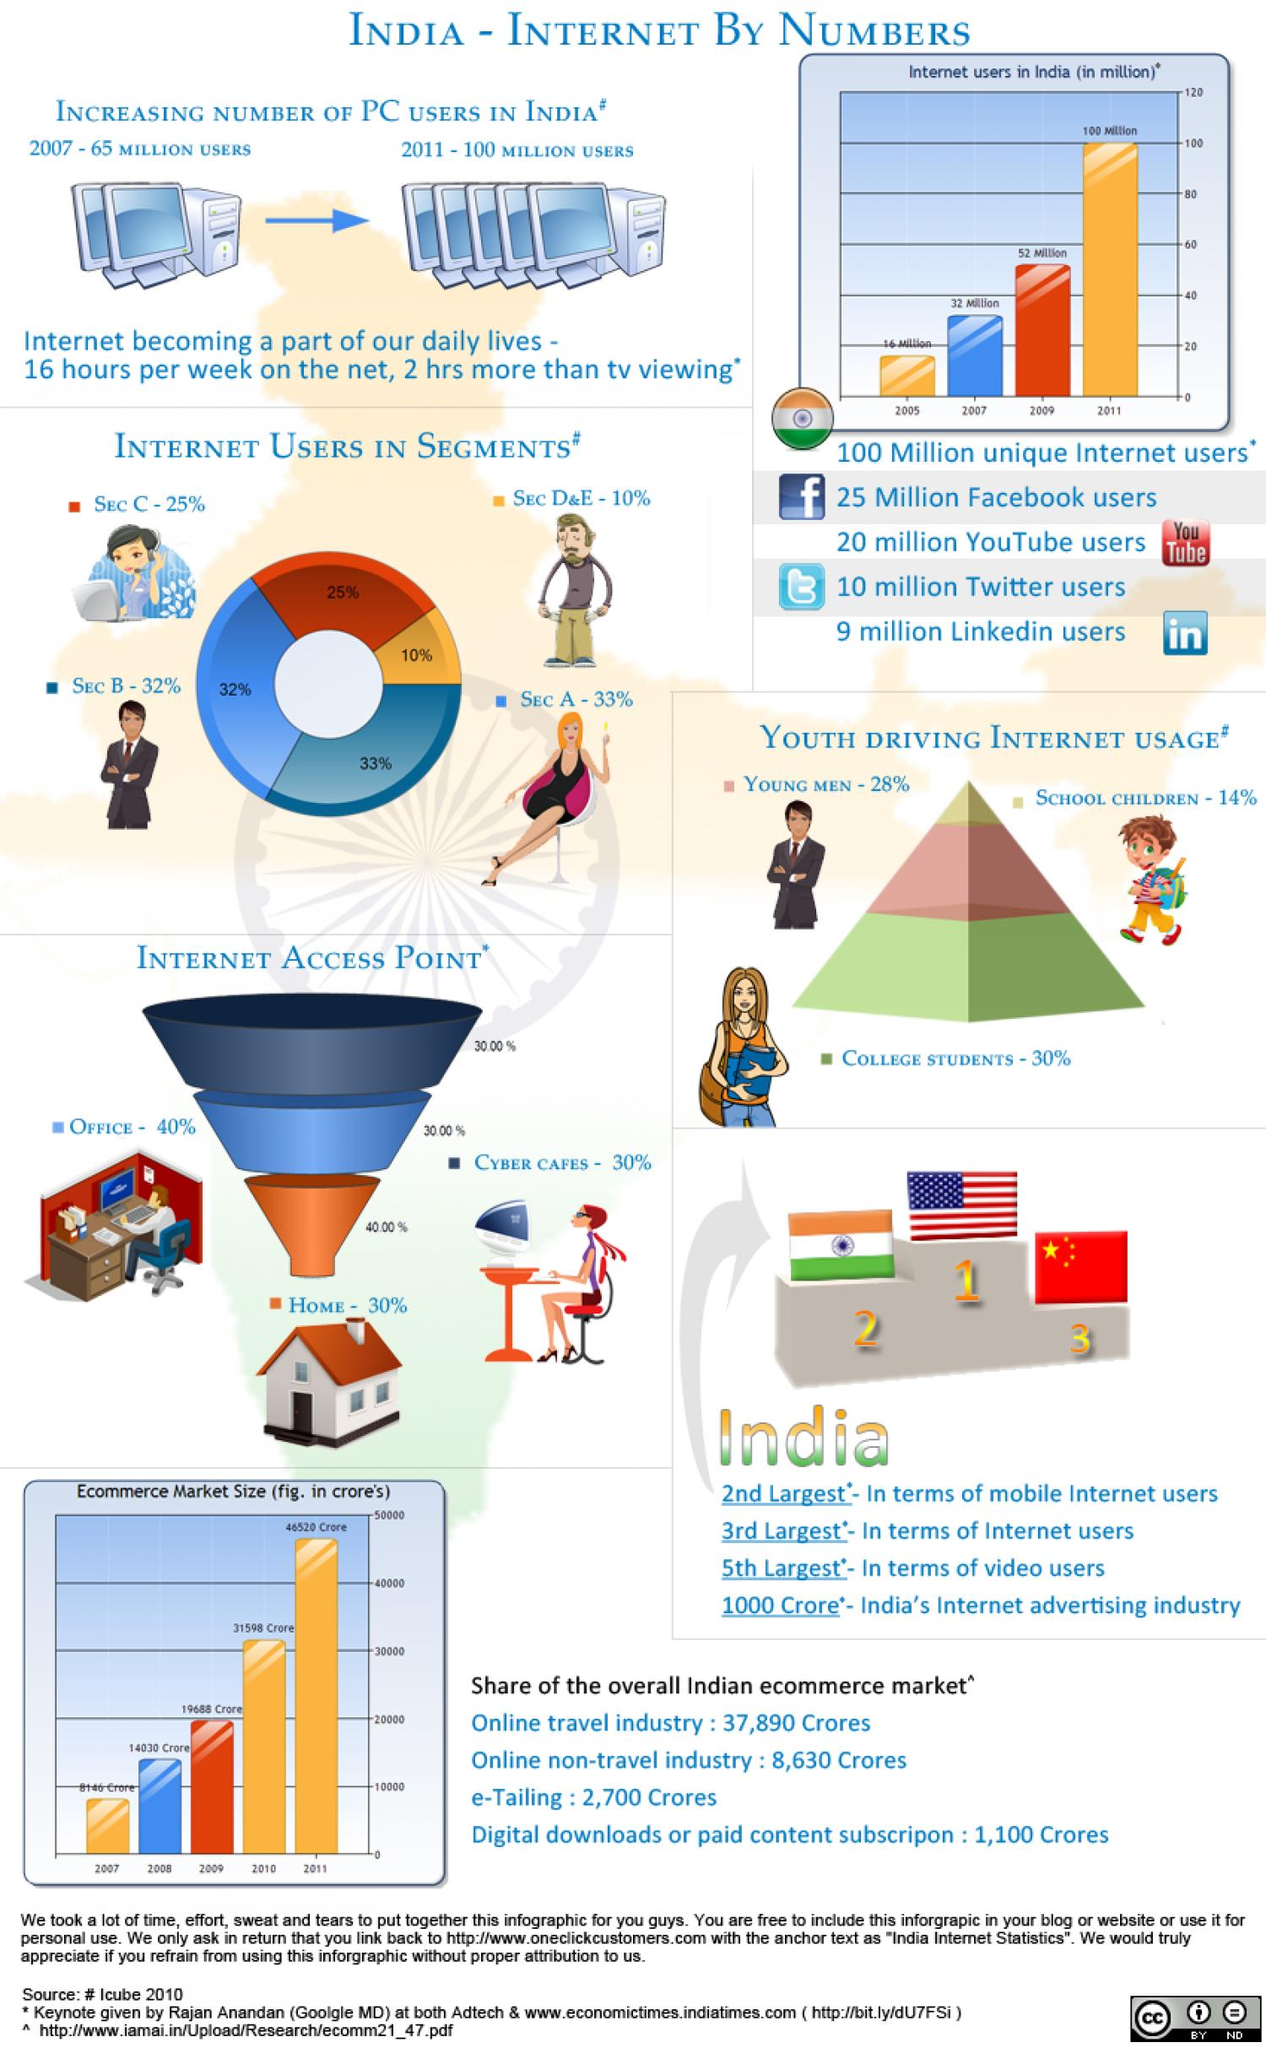Outline some significant characteristics in this image. The number of internet users in India increased by approximately 20 million from 2007 to 2009. The segment with the highest percentage of internet users is Sec B. The country with the largest number of internet users is China, followed by India, and then the United States. There was a 35 million user increase from 2007 to 2011. According to a recent survey, a majority of users, approximately 70%, are using the internet at both home and work. 